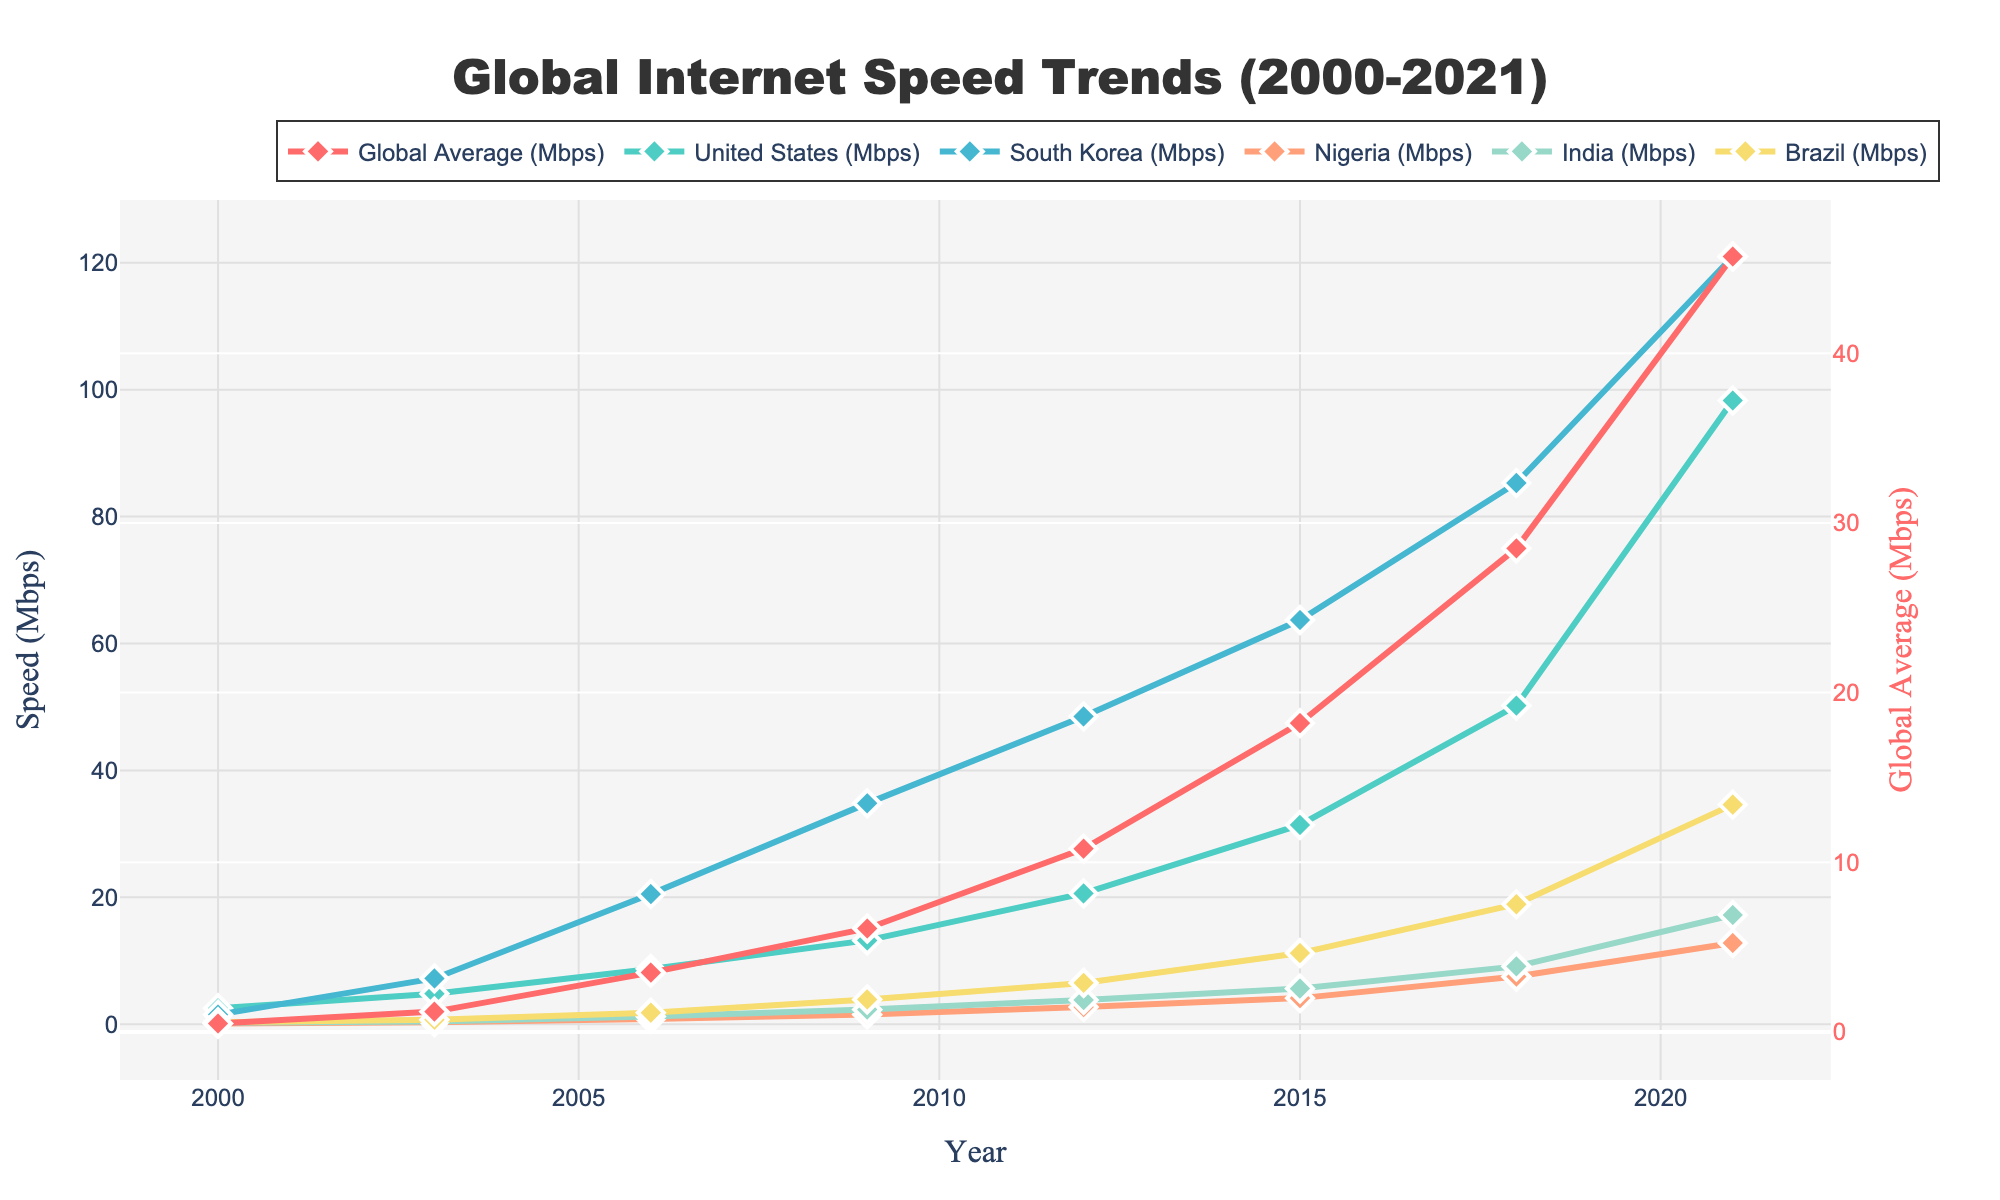Which country had the highest internet speed in 2021? To determine the highest internet speed in 2021, observe the lines corresponding to each country for 2021. South Korea's line is at the highest point, indicating its speed was 121.0 Mbps.
Answer: South Korea Compare the internet speeds of the United States and India in 2009. Which country had the higher speed and by how much? Refer to the lines for the United States and India in 2009. The United States had 13.2 Mbps, and India had 2.3 Mbps. Calculate the difference: 13.2 - 2.3 = 10.9 Mbps.
Answer: United States, 10.9 Mbps What is the trend of global average internet speeds from 2000 to 2021? Look at the line representing global average speeds. From 2000 to 2021, it steadily increases from 0.5 Mbps to 45.7 Mbps.
Answer: Steady increase Which year saw Nigeria's internet speed surpass 4 Mbps? Check Nigeria's internet speed line. It crosses 4 Mbps between 2012 and 2015, specifically reaching 4.1 Mbps in 2015.
Answer: 2015 By how much did Brazil's internet speed increase from 2000 to 2021? Find Brazil's speeds: 0.3 Mbps in 2000 and 34.6 Mbps in 2021. Calculate the difference: 34.6 - 0.3 = 34.3 Mbps.
Answer: 34.3 Mbps Compare the internet speed trends of developing nations (Nigeria, India, Brazil) from 2000 to 2021. Observe the lines for Nigeria, India, and Brazil. All show an upward trend but at different rates. Nigeria starts very low but shows gradual increases. India and Brazil show faster increases after 2006, with Brazil reaching 34.6 Mbps and India at 17.2 Mbps by 2021.
Answer: Gradual but varying rates of increase What is the visual difference in the markers used for the data points? Observe the graphical marks. The data points are represented by diamond-shaped markers, with the lines connected to each marker using different colors.
Answer: Diamond-shaped markers with different colors Which country had the lowest internet speed in 2006, and what was it? Refer to the lines for each country in 2006. Nigeria's line is closest to the bottom, indicating its speed was 0.8 Mbps.
Answer: Nigeria, 0.8 Mbps 